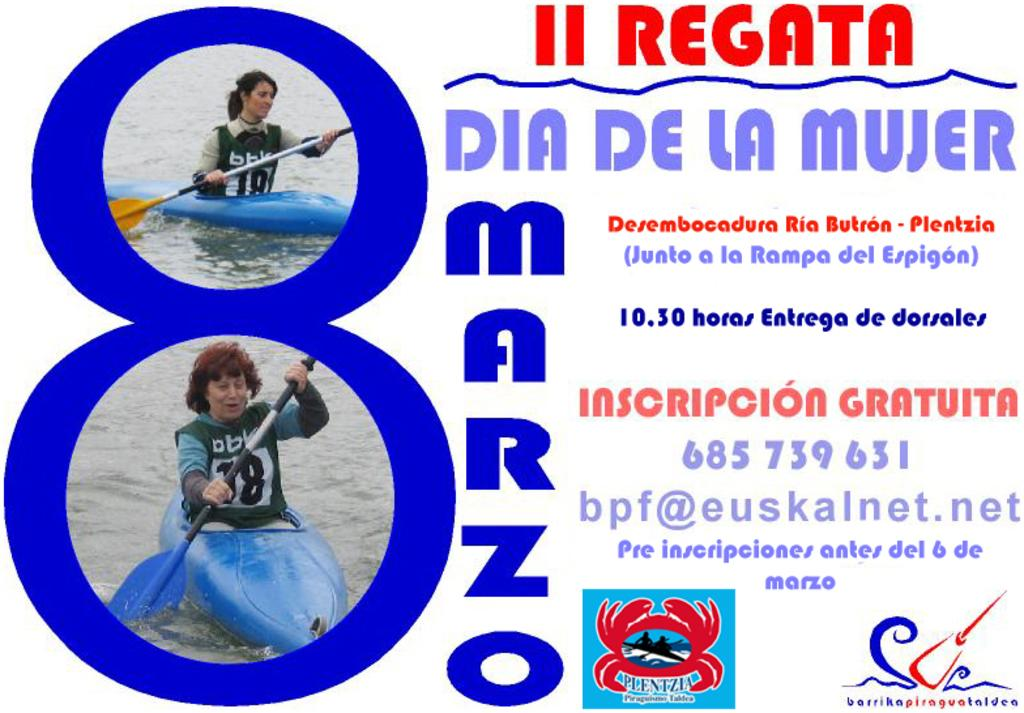What is featured on the poster in the image? There is a poster in the image, and it has text on it. Can you describe any other elements related to the poster? There are logos in the image. What activity is taking place in the image? There are people rowing water crafts in the image. What type of trousers are the fowl wearing while walking down the street in the image? There are no fowl or trousers present in the image, and no one is walking down a street. 